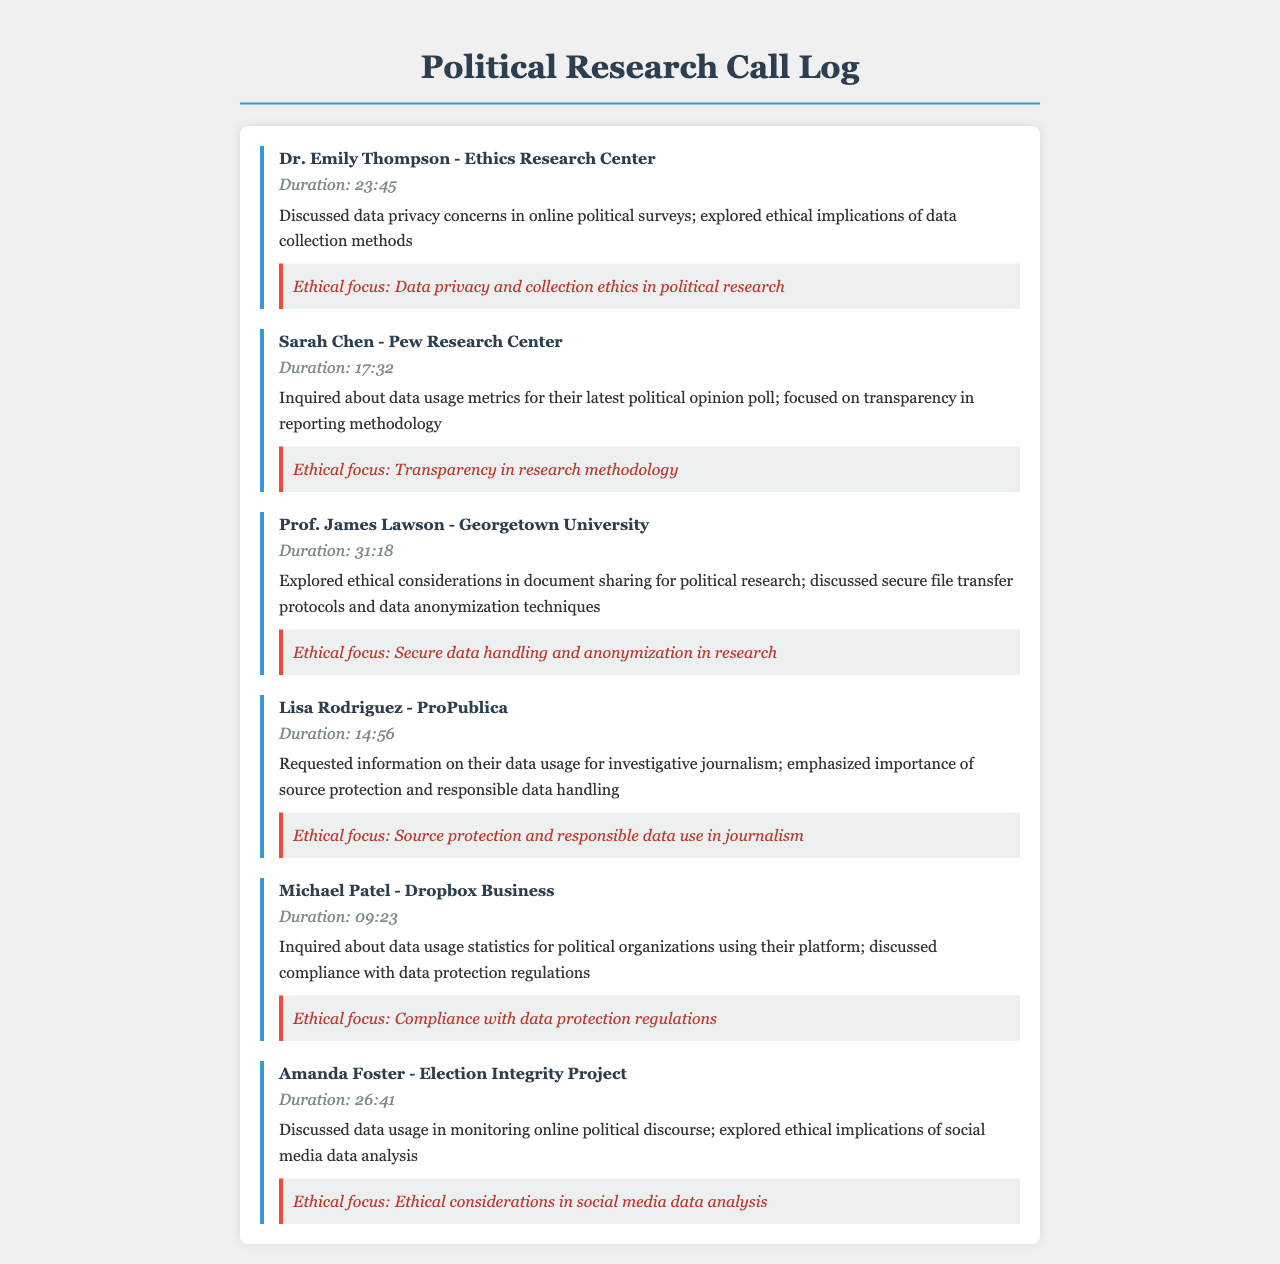What is the duration of the call with Dr. Emily Thompson? The duration is indicated in the call entry for Dr. Emily Thompson, which is 23:45.
Answer: 23:45 What ethical focus was discussed in the call with Sarah Chen? The ethical focus mentioned in connection with Sarah Chen's call is transparency in research methodology.
Answer: Transparency in research methodology Who did Prof. James Lawson represent during the call? The name mentioned is Prof. James Lawson, who is from Georgetown University.
Answer: Georgetown University What was the main topic of discussion with Lisa Rodriguez? The main topic discussed in the call with Lisa Rodriguez focused on data usage for investigative journalism.
Answer: Data usage for investigative journalism How long was the call with Amanda Foster? The duration is explicitly mentioned for Amanda Foster's call, which lasted for 26:41.
Answer: 26:41 Which organization was inquired about regarding data usage statistics by Michael Patel? The organization mentioned is Dropbox Business, where Michael Patel inquired about data usage statistics for political organizations.
Answer: Dropbox Business What ethical considerations were discussed in the call with Prof. James Lawson? The call focused on secure data handling and anonymization techniques as ethical considerations.
Answer: Secure data handling and anonymization What type of work is Lisa Rodriguez associated with? The document states that Lisa Rodriguez is associated with ProPublica.
Answer: ProPublica What was discussed regarding social media data analysis in the call with Amanda Foster? The ethical implications of social media data analysis were explored in the call with Amanda Foster.
Answer: Ethical implications of social media data analysis 